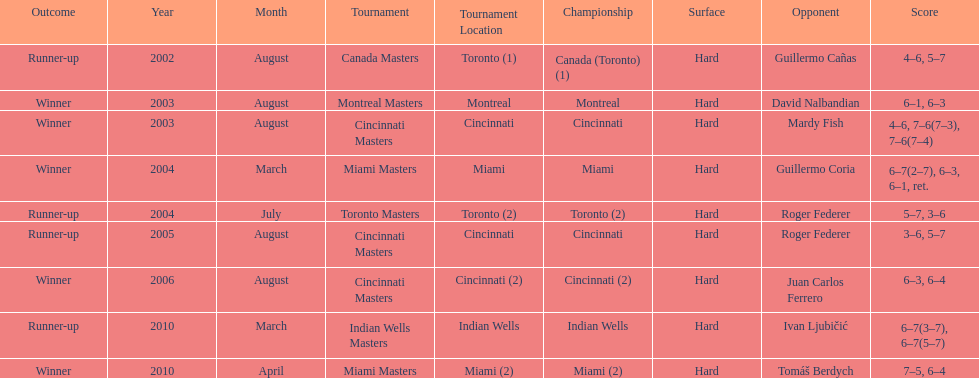How many times were roddick's opponents not from the usa? 8. 